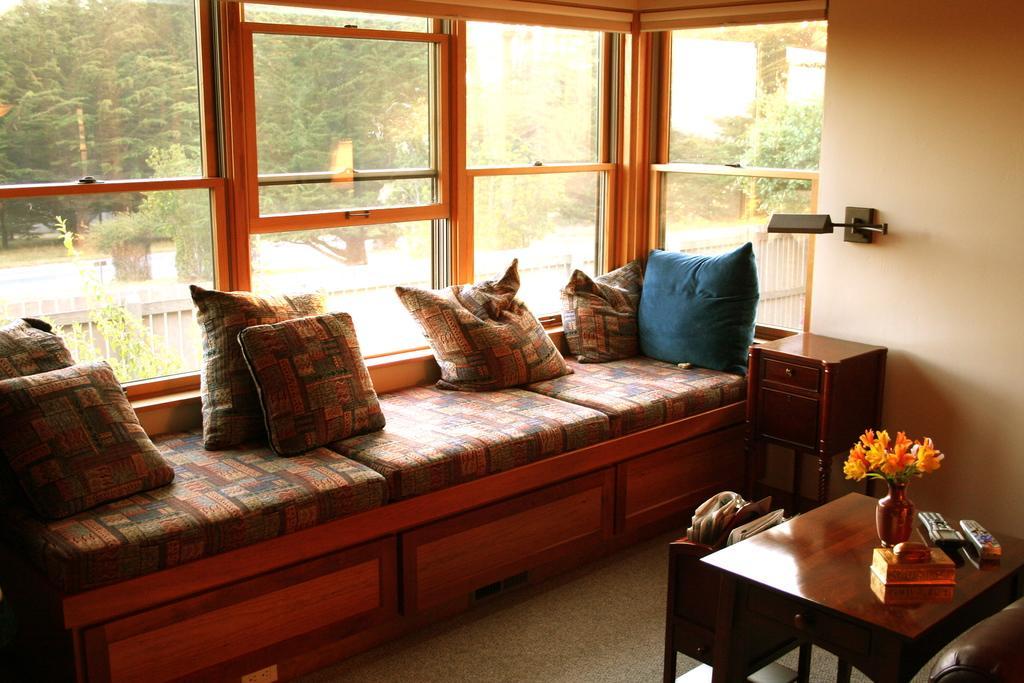In one or two sentences, can you explain what this image depicts? As we can see in the image, there are trees, plants, window, sofa, pillows, a table. On table there are remotes and flask. 